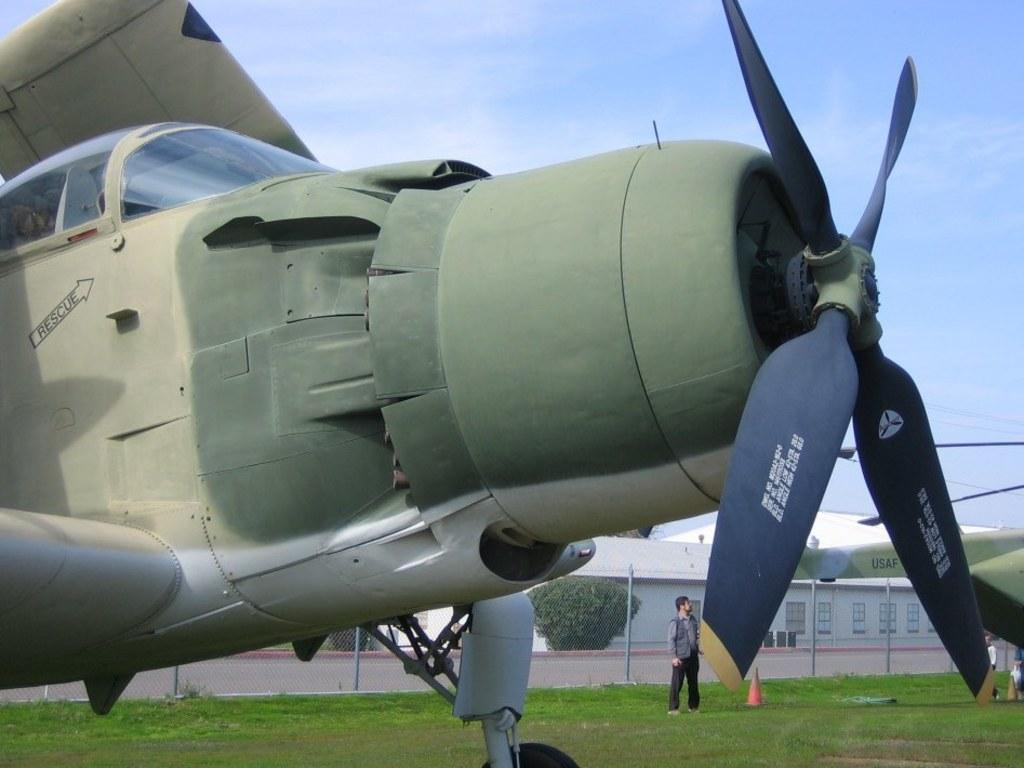<image>
Describe the image concisely. A plane has an arrow with the word rescue pointing to the pilots window. 